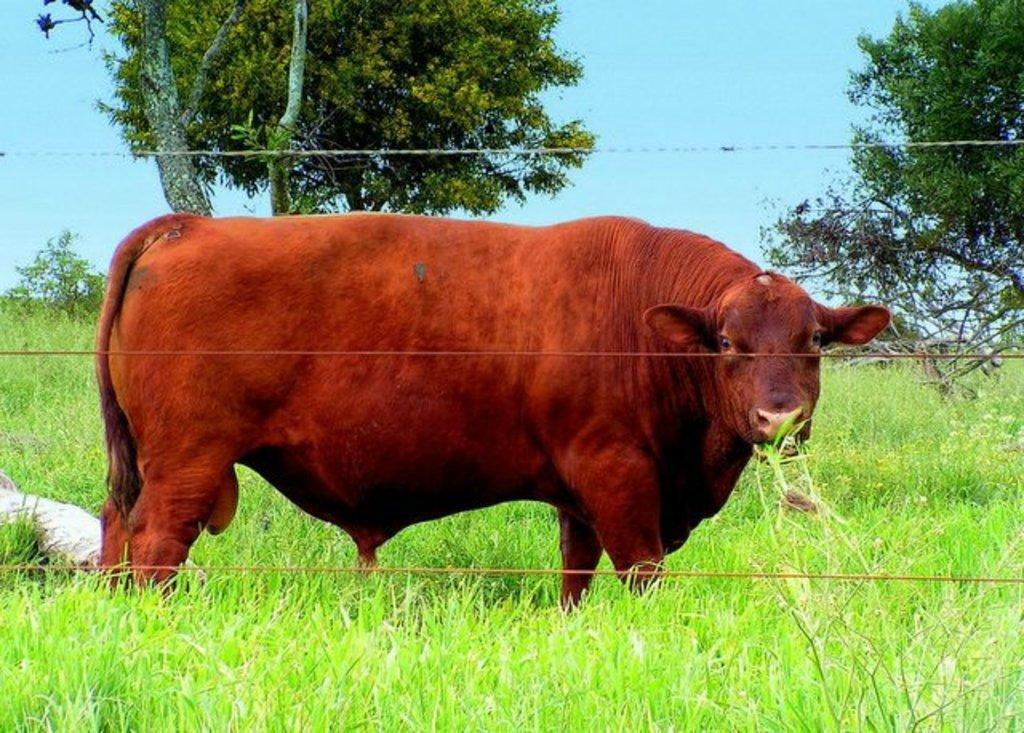What animal is the main subject of the image? There is a bull in the image. Where is the bull located? The bull is standing on grassland. Is there any barrier between the bull and its surroundings? Yes, the bull is behind a fence. What can be seen in the background of the image? There are trees and the sky visible in the background of the image. What type of owl can be seen perched on the fence in the image? There is no owl present in the image; it features a bull standing on grassland behind a fence. What role does the manager play in the image? There is no manager present in the image, as it only features a bull in a natural setting. 